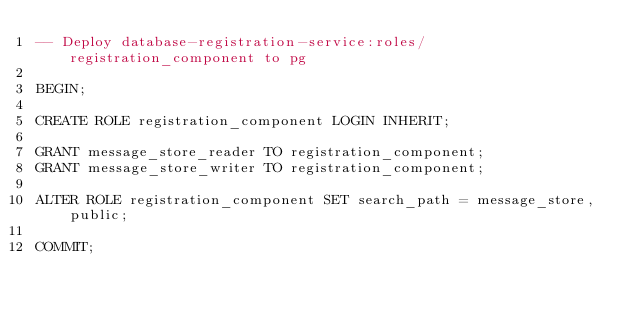<code> <loc_0><loc_0><loc_500><loc_500><_SQL_>-- Deploy database-registration-service:roles/registration_component to pg

BEGIN;

CREATE ROLE registration_component LOGIN INHERIT;

GRANT message_store_reader TO registration_component;
GRANT message_store_writer TO registration_component;

ALTER ROLE registration_component SET search_path = message_store, public;

COMMIT;
</code> 